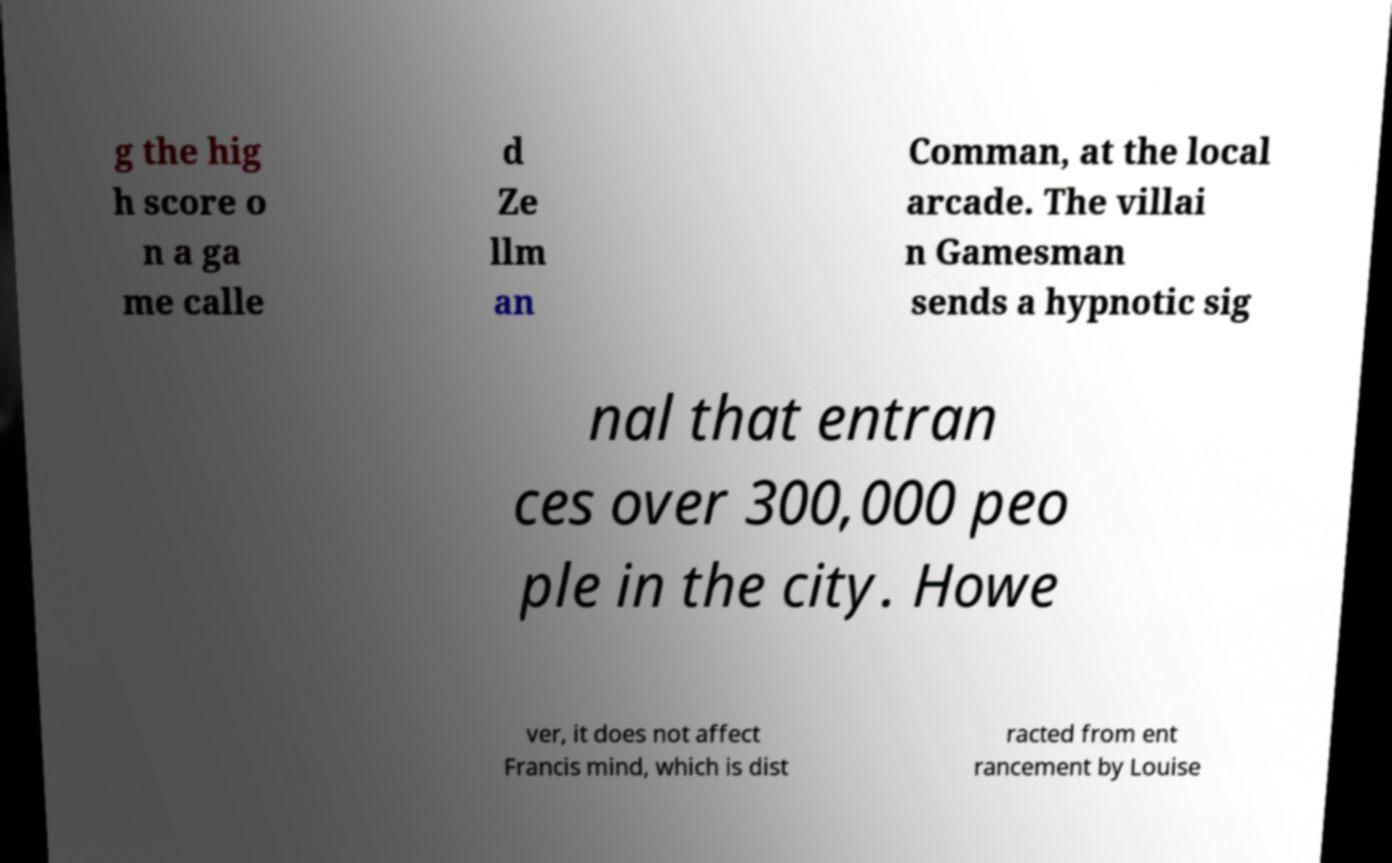Please read and relay the text visible in this image. What does it say? g the hig h score o n a ga me calle d Ze llm an Comman, at the local arcade. The villai n Gamesman sends a hypnotic sig nal that entran ces over 300,000 peo ple in the city. Howe ver, it does not affect Francis mind, which is dist racted from ent rancement by Louise 